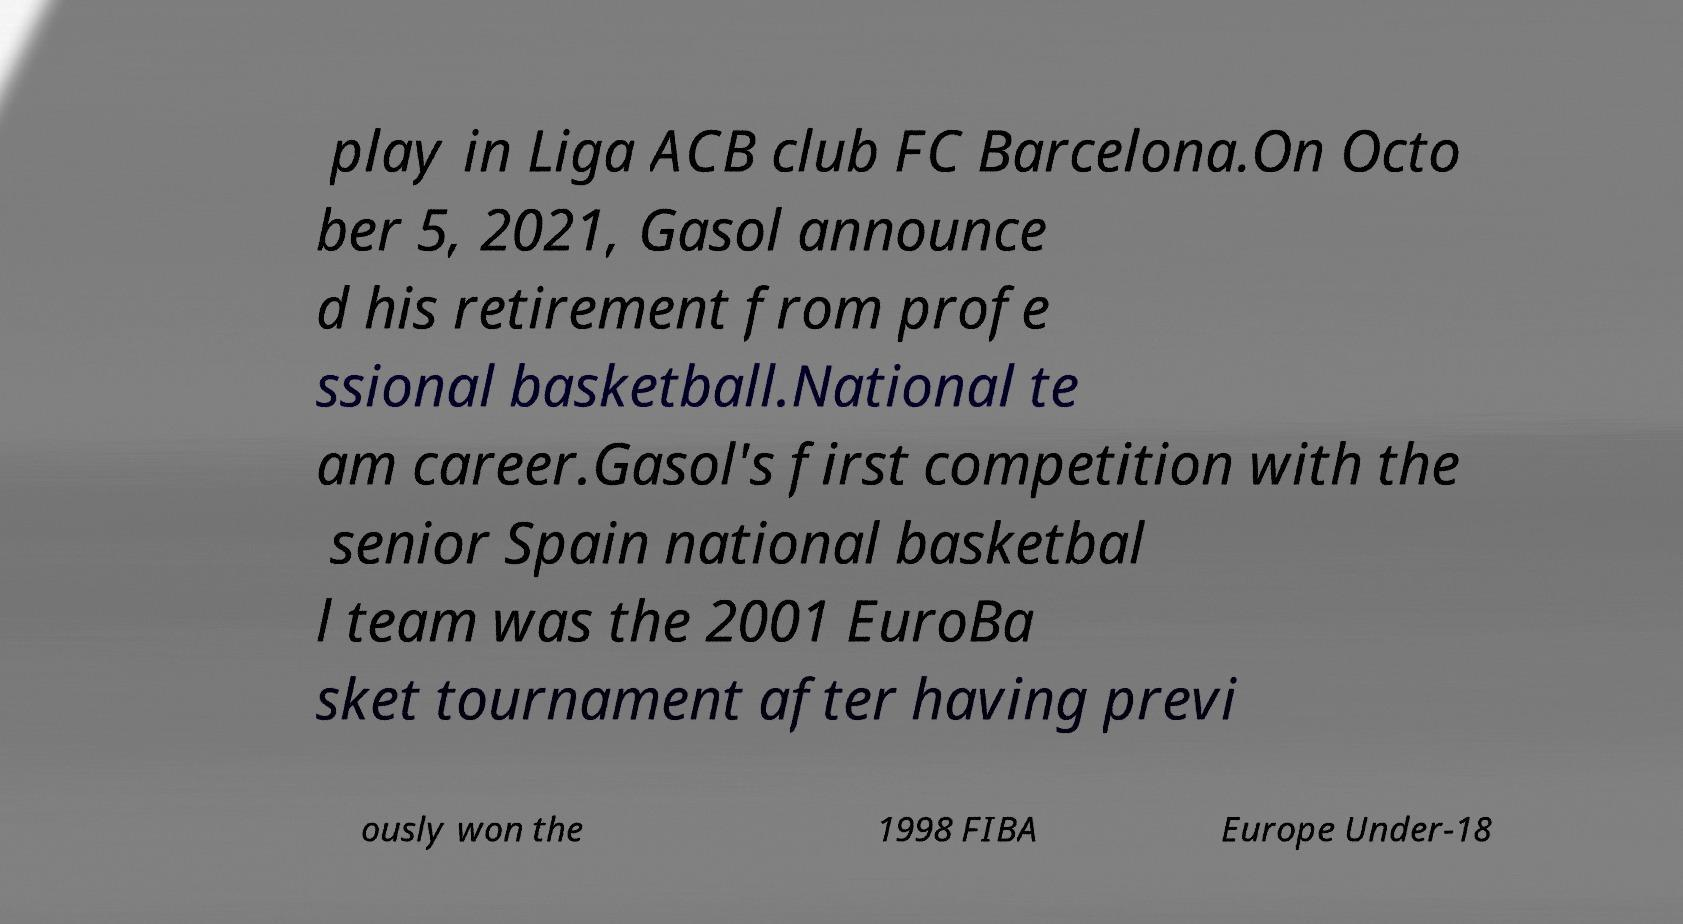Could you extract and type out the text from this image? play in Liga ACB club FC Barcelona.On Octo ber 5, 2021, Gasol announce d his retirement from profe ssional basketball.National te am career.Gasol's first competition with the senior Spain national basketbal l team was the 2001 EuroBa sket tournament after having previ ously won the 1998 FIBA Europe Under-18 